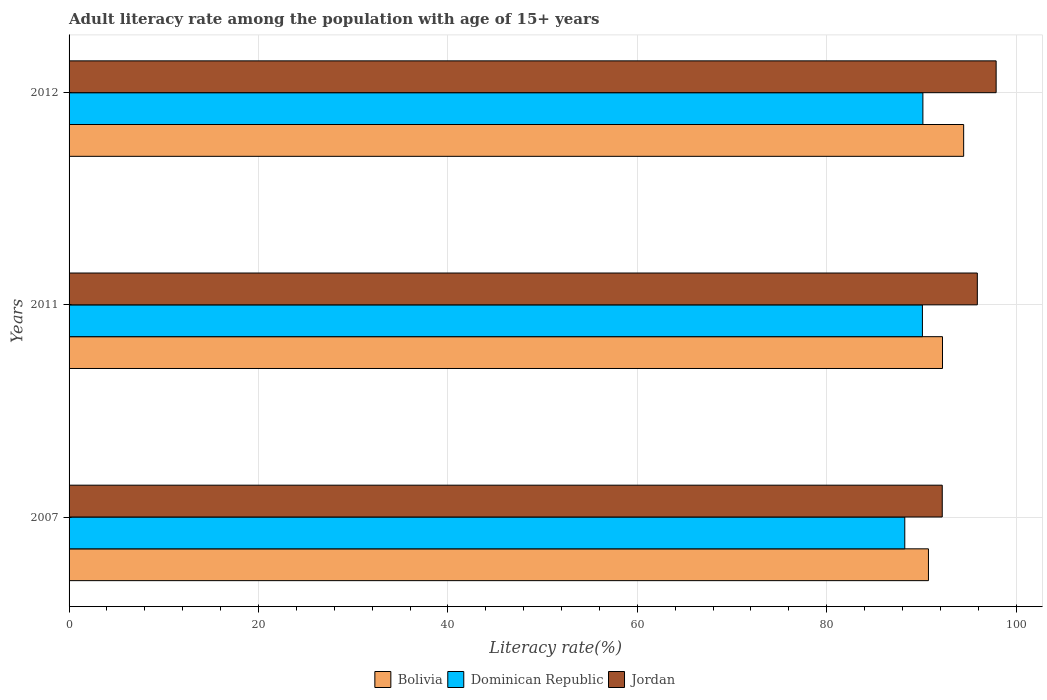Are the number of bars per tick equal to the number of legend labels?
Provide a succinct answer. Yes. What is the adult literacy rate in Jordan in 2011?
Your answer should be compact. 95.9. Across all years, what is the maximum adult literacy rate in Jordan?
Keep it short and to the point. 97.89. Across all years, what is the minimum adult literacy rate in Bolivia?
Ensure brevity in your answer.  90.74. In which year was the adult literacy rate in Bolivia maximum?
Provide a short and direct response. 2012. What is the total adult literacy rate in Bolivia in the graph?
Your response must be concise. 277.43. What is the difference between the adult literacy rate in Bolivia in 2007 and that in 2012?
Provide a succinct answer. -3.72. What is the difference between the adult literacy rate in Dominican Republic in 2007 and the adult literacy rate in Bolivia in 2012?
Keep it short and to the point. -6.22. What is the average adult literacy rate in Dominican Republic per year?
Provide a short and direct response. 89.5. In the year 2007, what is the difference between the adult literacy rate in Dominican Republic and adult literacy rate in Bolivia?
Your answer should be compact. -2.5. What is the ratio of the adult literacy rate in Jordan in 2007 to that in 2012?
Your response must be concise. 0.94. Is the adult literacy rate in Bolivia in 2007 less than that in 2011?
Your answer should be very brief. Yes. What is the difference between the highest and the second highest adult literacy rate in Jordan?
Provide a short and direct response. 1.99. What is the difference between the highest and the lowest adult literacy rate in Jordan?
Offer a terse response. 5.69. What does the 1st bar from the top in 2007 represents?
Your response must be concise. Jordan. What does the 2nd bar from the bottom in 2007 represents?
Keep it short and to the point. Dominican Republic. How many years are there in the graph?
Give a very brief answer. 3. What is the difference between two consecutive major ticks on the X-axis?
Make the answer very short. 20. Does the graph contain any zero values?
Give a very brief answer. No. How are the legend labels stacked?
Your answer should be very brief. Horizontal. What is the title of the graph?
Provide a succinct answer. Adult literacy rate among the population with age of 15+ years. Does "Russian Federation" appear as one of the legend labels in the graph?
Provide a succinct answer. No. What is the label or title of the X-axis?
Your answer should be very brief. Literacy rate(%). What is the Literacy rate(%) of Bolivia in 2007?
Provide a short and direct response. 90.74. What is the Literacy rate(%) of Dominican Republic in 2007?
Keep it short and to the point. 88.24. What is the Literacy rate(%) of Jordan in 2007?
Offer a very short reply. 92.2. What is the Literacy rate(%) in Bolivia in 2011?
Make the answer very short. 92.23. What is the Literacy rate(%) in Dominican Republic in 2011?
Provide a succinct answer. 90.11. What is the Literacy rate(%) of Jordan in 2011?
Provide a short and direct response. 95.9. What is the Literacy rate(%) of Bolivia in 2012?
Keep it short and to the point. 94.46. What is the Literacy rate(%) of Dominican Republic in 2012?
Your answer should be compact. 90.16. What is the Literacy rate(%) of Jordan in 2012?
Your response must be concise. 97.89. Across all years, what is the maximum Literacy rate(%) of Bolivia?
Ensure brevity in your answer.  94.46. Across all years, what is the maximum Literacy rate(%) of Dominican Republic?
Provide a succinct answer. 90.16. Across all years, what is the maximum Literacy rate(%) of Jordan?
Provide a succinct answer. 97.89. Across all years, what is the minimum Literacy rate(%) of Bolivia?
Offer a terse response. 90.74. Across all years, what is the minimum Literacy rate(%) of Dominican Republic?
Your answer should be compact. 88.24. Across all years, what is the minimum Literacy rate(%) in Jordan?
Your response must be concise. 92.2. What is the total Literacy rate(%) of Bolivia in the graph?
Keep it short and to the point. 277.43. What is the total Literacy rate(%) of Dominican Republic in the graph?
Keep it short and to the point. 268.51. What is the total Literacy rate(%) of Jordan in the graph?
Ensure brevity in your answer.  285.99. What is the difference between the Literacy rate(%) of Bolivia in 2007 and that in 2011?
Your answer should be very brief. -1.48. What is the difference between the Literacy rate(%) in Dominican Republic in 2007 and that in 2011?
Ensure brevity in your answer.  -1.86. What is the difference between the Literacy rate(%) of Jordan in 2007 and that in 2011?
Make the answer very short. -3.7. What is the difference between the Literacy rate(%) of Bolivia in 2007 and that in 2012?
Give a very brief answer. -3.72. What is the difference between the Literacy rate(%) in Dominican Republic in 2007 and that in 2012?
Give a very brief answer. -1.91. What is the difference between the Literacy rate(%) in Jordan in 2007 and that in 2012?
Your answer should be compact. -5.69. What is the difference between the Literacy rate(%) of Bolivia in 2011 and that in 2012?
Offer a very short reply. -2.23. What is the difference between the Literacy rate(%) of Dominican Republic in 2011 and that in 2012?
Your answer should be compact. -0.05. What is the difference between the Literacy rate(%) of Jordan in 2011 and that in 2012?
Offer a terse response. -1.99. What is the difference between the Literacy rate(%) in Bolivia in 2007 and the Literacy rate(%) in Dominican Republic in 2011?
Your answer should be very brief. 0.64. What is the difference between the Literacy rate(%) in Bolivia in 2007 and the Literacy rate(%) in Jordan in 2011?
Provide a short and direct response. -5.16. What is the difference between the Literacy rate(%) of Dominican Republic in 2007 and the Literacy rate(%) of Jordan in 2011?
Your response must be concise. -7.66. What is the difference between the Literacy rate(%) in Bolivia in 2007 and the Literacy rate(%) in Dominican Republic in 2012?
Keep it short and to the point. 0.59. What is the difference between the Literacy rate(%) in Bolivia in 2007 and the Literacy rate(%) in Jordan in 2012?
Your response must be concise. -7.15. What is the difference between the Literacy rate(%) of Dominican Republic in 2007 and the Literacy rate(%) of Jordan in 2012?
Keep it short and to the point. -9.65. What is the difference between the Literacy rate(%) of Bolivia in 2011 and the Literacy rate(%) of Dominican Republic in 2012?
Your answer should be very brief. 2.07. What is the difference between the Literacy rate(%) of Bolivia in 2011 and the Literacy rate(%) of Jordan in 2012?
Your answer should be compact. -5.66. What is the difference between the Literacy rate(%) in Dominican Republic in 2011 and the Literacy rate(%) in Jordan in 2012?
Ensure brevity in your answer.  -7.78. What is the average Literacy rate(%) in Bolivia per year?
Your answer should be compact. 92.48. What is the average Literacy rate(%) of Dominican Republic per year?
Give a very brief answer. 89.5. What is the average Literacy rate(%) in Jordan per year?
Your response must be concise. 95.33. In the year 2007, what is the difference between the Literacy rate(%) in Bolivia and Literacy rate(%) in Dominican Republic?
Keep it short and to the point. 2.5. In the year 2007, what is the difference between the Literacy rate(%) of Bolivia and Literacy rate(%) of Jordan?
Provide a short and direct response. -1.46. In the year 2007, what is the difference between the Literacy rate(%) in Dominican Republic and Literacy rate(%) in Jordan?
Provide a short and direct response. -3.96. In the year 2011, what is the difference between the Literacy rate(%) of Bolivia and Literacy rate(%) of Dominican Republic?
Ensure brevity in your answer.  2.12. In the year 2011, what is the difference between the Literacy rate(%) in Bolivia and Literacy rate(%) in Jordan?
Give a very brief answer. -3.68. In the year 2011, what is the difference between the Literacy rate(%) of Dominican Republic and Literacy rate(%) of Jordan?
Provide a short and direct response. -5.8. In the year 2012, what is the difference between the Literacy rate(%) of Bolivia and Literacy rate(%) of Dominican Republic?
Your answer should be compact. 4.31. In the year 2012, what is the difference between the Literacy rate(%) of Bolivia and Literacy rate(%) of Jordan?
Keep it short and to the point. -3.43. In the year 2012, what is the difference between the Literacy rate(%) of Dominican Republic and Literacy rate(%) of Jordan?
Offer a terse response. -7.74. What is the ratio of the Literacy rate(%) in Bolivia in 2007 to that in 2011?
Your answer should be compact. 0.98. What is the ratio of the Literacy rate(%) in Dominican Republic in 2007 to that in 2011?
Give a very brief answer. 0.98. What is the ratio of the Literacy rate(%) of Jordan in 2007 to that in 2011?
Ensure brevity in your answer.  0.96. What is the ratio of the Literacy rate(%) of Bolivia in 2007 to that in 2012?
Keep it short and to the point. 0.96. What is the ratio of the Literacy rate(%) in Dominican Republic in 2007 to that in 2012?
Make the answer very short. 0.98. What is the ratio of the Literacy rate(%) in Jordan in 2007 to that in 2012?
Give a very brief answer. 0.94. What is the ratio of the Literacy rate(%) of Bolivia in 2011 to that in 2012?
Provide a short and direct response. 0.98. What is the ratio of the Literacy rate(%) in Jordan in 2011 to that in 2012?
Your answer should be very brief. 0.98. What is the difference between the highest and the second highest Literacy rate(%) of Bolivia?
Ensure brevity in your answer.  2.23. What is the difference between the highest and the second highest Literacy rate(%) of Dominican Republic?
Provide a succinct answer. 0.05. What is the difference between the highest and the second highest Literacy rate(%) of Jordan?
Your answer should be compact. 1.99. What is the difference between the highest and the lowest Literacy rate(%) in Bolivia?
Your response must be concise. 3.72. What is the difference between the highest and the lowest Literacy rate(%) in Dominican Republic?
Make the answer very short. 1.91. What is the difference between the highest and the lowest Literacy rate(%) of Jordan?
Provide a short and direct response. 5.69. 